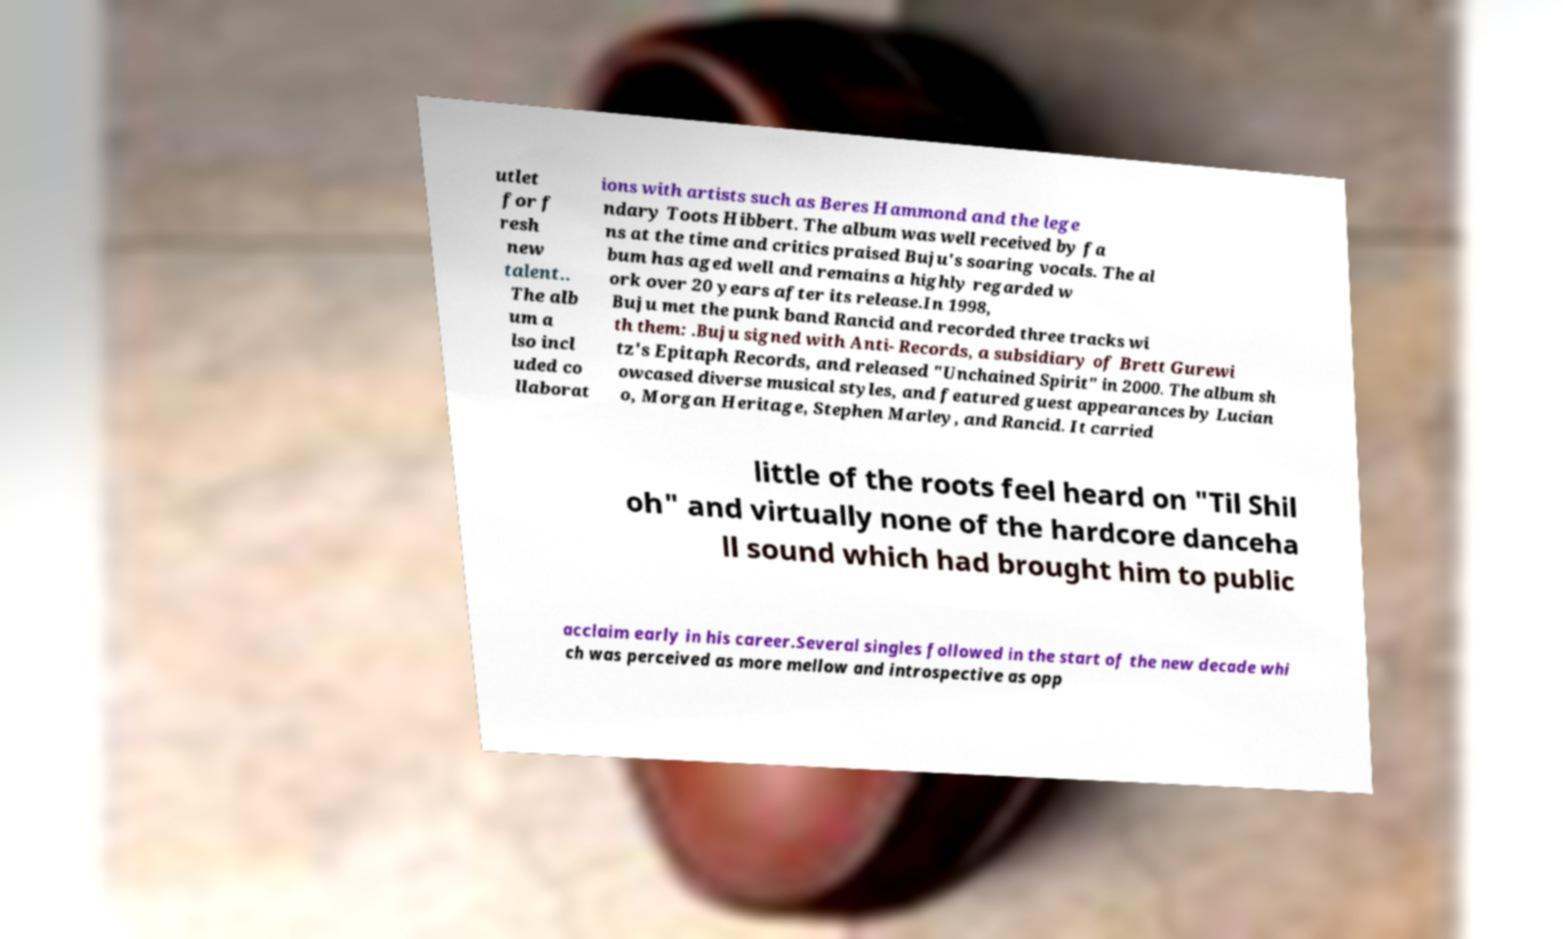What messages or text are displayed in this image? I need them in a readable, typed format. utlet for f resh new talent.. The alb um a lso incl uded co llaborat ions with artists such as Beres Hammond and the lege ndary Toots Hibbert. The album was well received by fa ns at the time and critics praised Buju's soaring vocals. The al bum has aged well and remains a highly regarded w ork over 20 years after its release.In 1998, Buju met the punk band Rancid and recorded three tracks wi th them: .Buju signed with Anti- Records, a subsidiary of Brett Gurewi tz's Epitaph Records, and released "Unchained Spirit" in 2000. The album sh owcased diverse musical styles, and featured guest appearances by Lucian o, Morgan Heritage, Stephen Marley, and Rancid. It carried little of the roots feel heard on "Til Shil oh" and virtually none of the hardcore danceha ll sound which had brought him to public acclaim early in his career.Several singles followed in the start of the new decade whi ch was perceived as more mellow and introspective as opp 